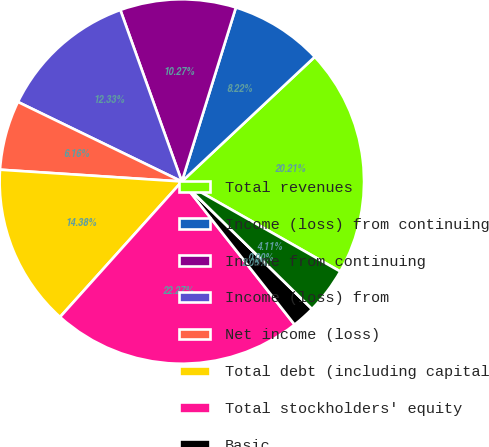Convert chart. <chart><loc_0><loc_0><loc_500><loc_500><pie_chart><fcel>Total revenues<fcel>Income (loss) from continuing<fcel>Income from continuing<fcel>Income (loss) from<fcel>Net income (loss)<fcel>Total debt (including capital<fcel>Total stockholders' equity<fcel>Basic<fcel>Diluted<fcel>Cash dividends declared per<nl><fcel>20.21%<fcel>8.22%<fcel>10.27%<fcel>12.33%<fcel>6.16%<fcel>14.38%<fcel>22.27%<fcel>2.05%<fcel>0.0%<fcel>4.11%<nl></chart> 